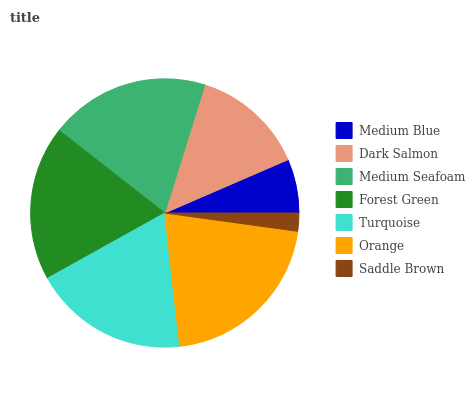Is Saddle Brown the minimum?
Answer yes or no. Yes. Is Orange the maximum?
Answer yes or no. Yes. Is Dark Salmon the minimum?
Answer yes or no. No. Is Dark Salmon the maximum?
Answer yes or no. No. Is Dark Salmon greater than Medium Blue?
Answer yes or no. Yes. Is Medium Blue less than Dark Salmon?
Answer yes or no. Yes. Is Medium Blue greater than Dark Salmon?
Answer yes or no. No. Is Dark Salmon less than Medium Blue?
Answer yes or no. No. Is Forest Green the high median?
Answer yes or no. Yes. Is Forest Green the low median?
Answer yes or no. Yes. Is Turquoise the high median?
Answer yes or no. No. Is Saddle Brown the low median?
Answer yes or no. No. 